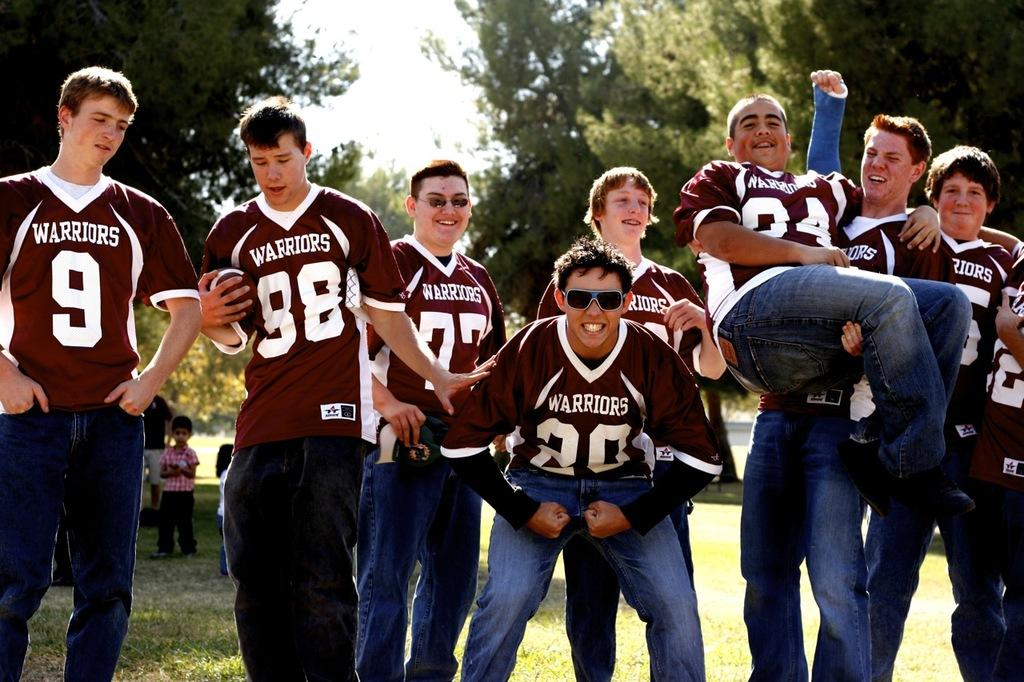<image>
Create a compact narrative representing the image presented. Men posing for a photo while wearing jerseys that say Warriors on it. 